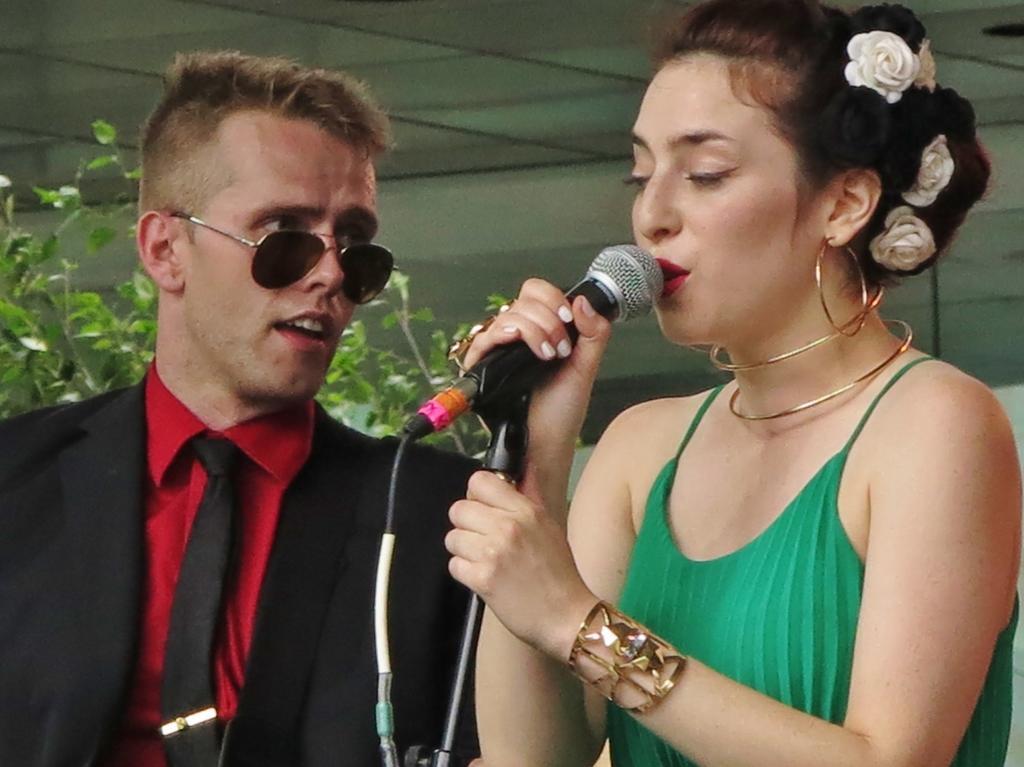Could you give a brief overview of what you see in this image? This picture shows a woman singing with help of a microphone and we see a man watching her and we see a plant back of them. 